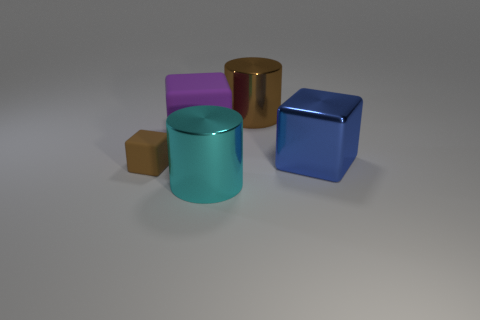Can you describe the colors and shapes of the objects seen in the image? There are five objects in various colors and shapes. Starting from the left, there's a small brown cube, a purple cylindrical object, a teal cylinder, a gold cube with rounded edges, and a larger blue cube. 